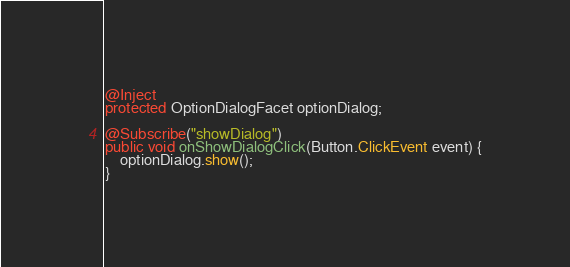Convert code to text. <code><loc_0><loc_0><loc_500><loc_500><_Java_>@Inject
protected OptionDialogFacet optionDialog;

@Subscribe("showDialog")
public void onShowDialogClick(Button.ClickEvent event) {
    optionDialog.show();
}</code> 